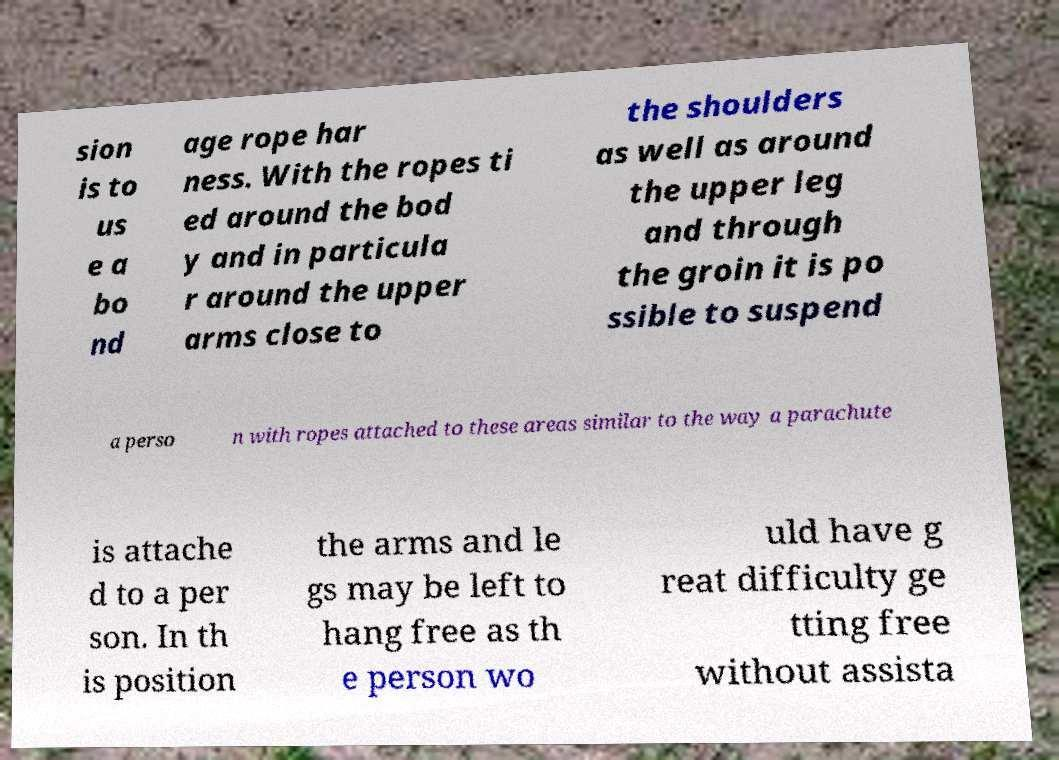There's text embedded in this image that I need extracted. Can you transcribe it verbatim? sion is to us e a bo nd age rope har ness. With the ropes ti ed around the bod y and in particula r around the upper arms close to the shoulders as well as around the upper leg and through the groin it is po ssible to suspend a perso n with ropes attached to these areas similar to the way a parachute is attache d to a per son. In th is position the arms and le gs may be left to hang free as th e person wo uld have g reat difficulty ge tting free without assista 